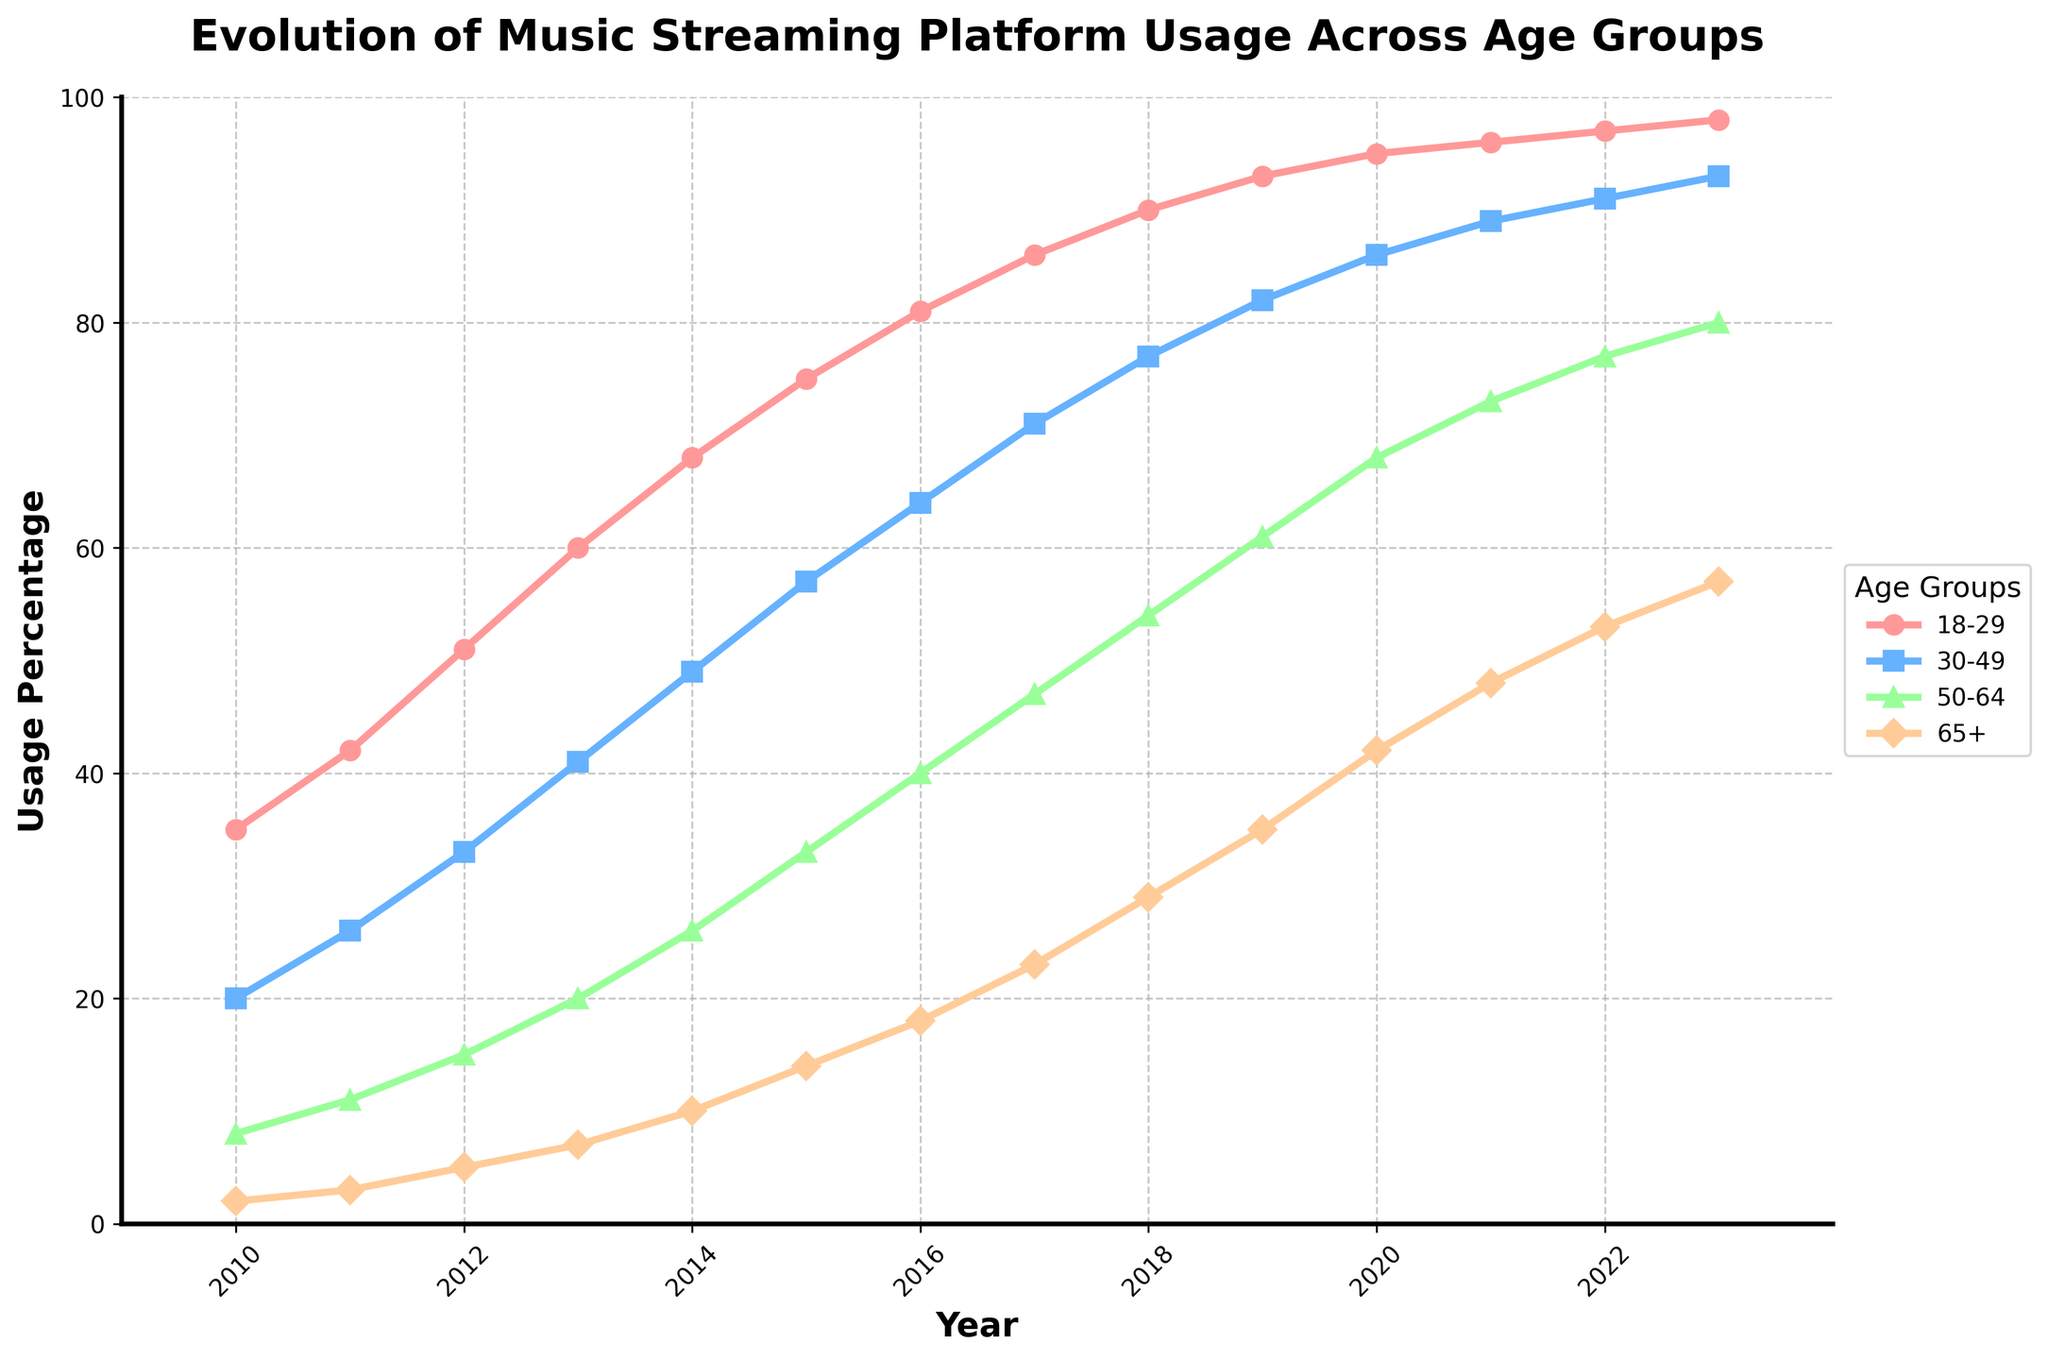Which age group had the highest usage percentage of music streaming platforms in 2010? To determine the highest usage percentage in 2010, look at the bars representing each age group for that year. The age group 18-29 had the highest usage with 35%.
Answer: 18-29 By how much did the usage percentage for the 65+ age group increase from 2010 to 2023? Find the usage percentage for the 65+ age group in 2010 (2%) and in 2023 (57%). Subtract the 2010 value from the 2023 value: 57% - 2% = 55%.
Answer: 55% Which age group showed the most significant absolute increase in usage percentage over the years 2010 to 2023? Calculate the increase for each age group by subtracting the 2010 value from the 2023 value: 
- (18-29): 98% - 35% = 63%
- (30-49): 93% - 20% = 73%
- (50-64): 80% - 8% = 72%
- (65+): 57% - 2% = 55%
The 30-49 age group had the most significant absolute increase of 73%.
Answer: 30-49 In which year did the 18-29 age group first reach 90% usage percentage? Look at the data points for the 18-29 age group and identify when it first reaches 90%. It reached 90% in 2018.
Answer: 2018 What is the average usage percentage for the 50-64 age group from 2010 to 2023? Add the percentages from each year for the 50-64 age group and then divide by the number of years (14):
(8 + 11 + 15 + 20 + 26 + 33 + 40 + 47 + 54 + 61 + 68 + 73 + 77 + 80) / 14 ≈ 46.79%.
Answer: 46.79% Which age group had the smallest usage percentage disparity between 2010 and 2023? Calculate the differences for each age group:
- (18-29): 98% - 35% = 63%
- (30-49): 93% - 20% = 73%
- (50-64): 80% - 8% = 72%
- (65+): 57% - 2% = 55%
The 65+ age group had the smallest disparity of 55%.
Answer: 65+ Did any age group have a consistently increasing trend from 2010 to 2023? Observing the plot, all age groups (18-29, 30-49, 50-64, 65+) show a consistently increasing trend over the years.
Answer: Yes Which year had the highest total combined usage percentage across all age groups? Sum the values for each age group for each year and find the year with the highest total:
2010: 35 + 20 + 8 + 2 = 65
2011: 42 + 26 + 11 + 3 = 82
2012: 51 + 33 + 15 + 5 = 104
2013: 60 + 41 + 20 + 7 = 128
2014: 68 + 49 + 26 + 10 = 153
2015: 75 + 57 + 33 + 14 = 179
2016: 81 + 64 + 40 + 18 = 203
2017: 86 + 71 + 47 + 23 = 227
2018: 90 + 77 + 54 + 29 = 250
2019: 93 + 82 + 61 + 35 = 271
2020: 95 + 86 + 68 + 42 = 291
2021: 96 + 89 + 73 + 48 = 306
2022: 97 + 91 + 77 + 53 = 318
2023: 98 + 93 + 80 + 57 = 328
2023 had the highest combined usage percentage of 328.
Answer: 2023 Among the four age groups, which one had the smallest increase when comparing 2019 and 2020? Calculate the difference for each age group:
- (18-29): 95% - 93% = 2%
- (30-49): 86% - 82% = 4%
- (50-64): 68% - 61% = 7%
- (65+): 42% - 35% = 7%
The 18-29 age group had the smallest increase of 2%.
Answer: 18-29 